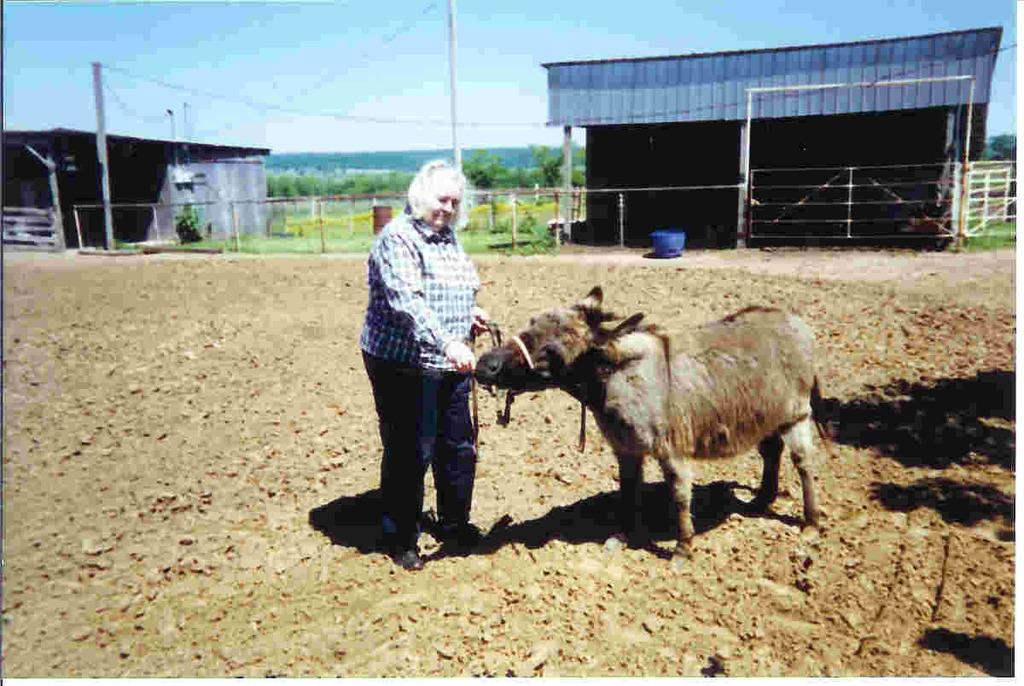What type of animal is in the image? There is an animal in the image, but the specific type cannot be determined from the facts provided. What is the person in the image doing? The person is on the ground, but their activity cannot be determined from the facts provided. What structures can be seen in the background of the image? There are sheds, poles, trees, and a fence in the background of the image. What else can be seen in the background of the image? There are some objects in the background of the image, and the sky is visible. What direction is the kite flying in the image? There is no kite present in the image, so it cannot be determined which direction it might be flying. 